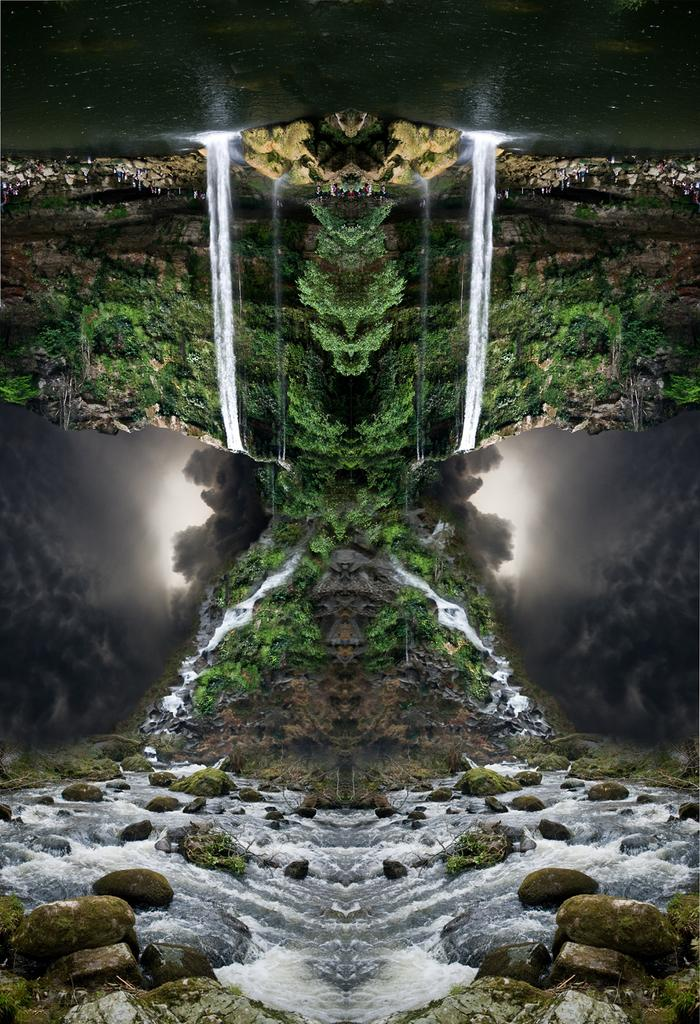What natural feature is the main subject of the image? There is a waterfall in the image. What else can be seen in the middle of the image? There are plants in the middle of the image. What is present at the bottom of the image? There are stones and water at the bottom of the image. How would you describe the style of the image? The image is graphical in nature. What type of leather is used to create the bean in the image? There is no leather or bean present in the image. 